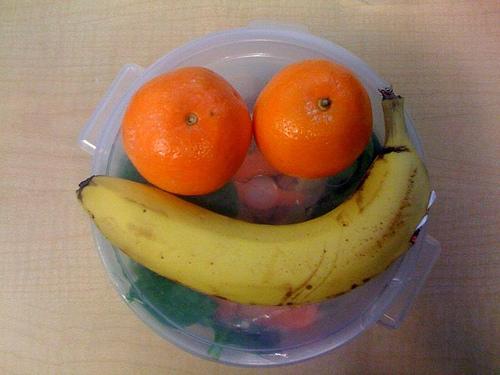What are the face's eyes made of?
Quick response, please. Oranges. What face does this make?
Write a very short answer. Smiley. How many different types of fruits are on the plate?
Short answer required. 2. Does the fruit look like a face?
Quick response, please. Yes. Do these look ripe?
Quick response, please. Yes. Are these fruits clean?
Short answer required. Yes. What is the fruit sitting in?
Write a very short answer. Bowl. 